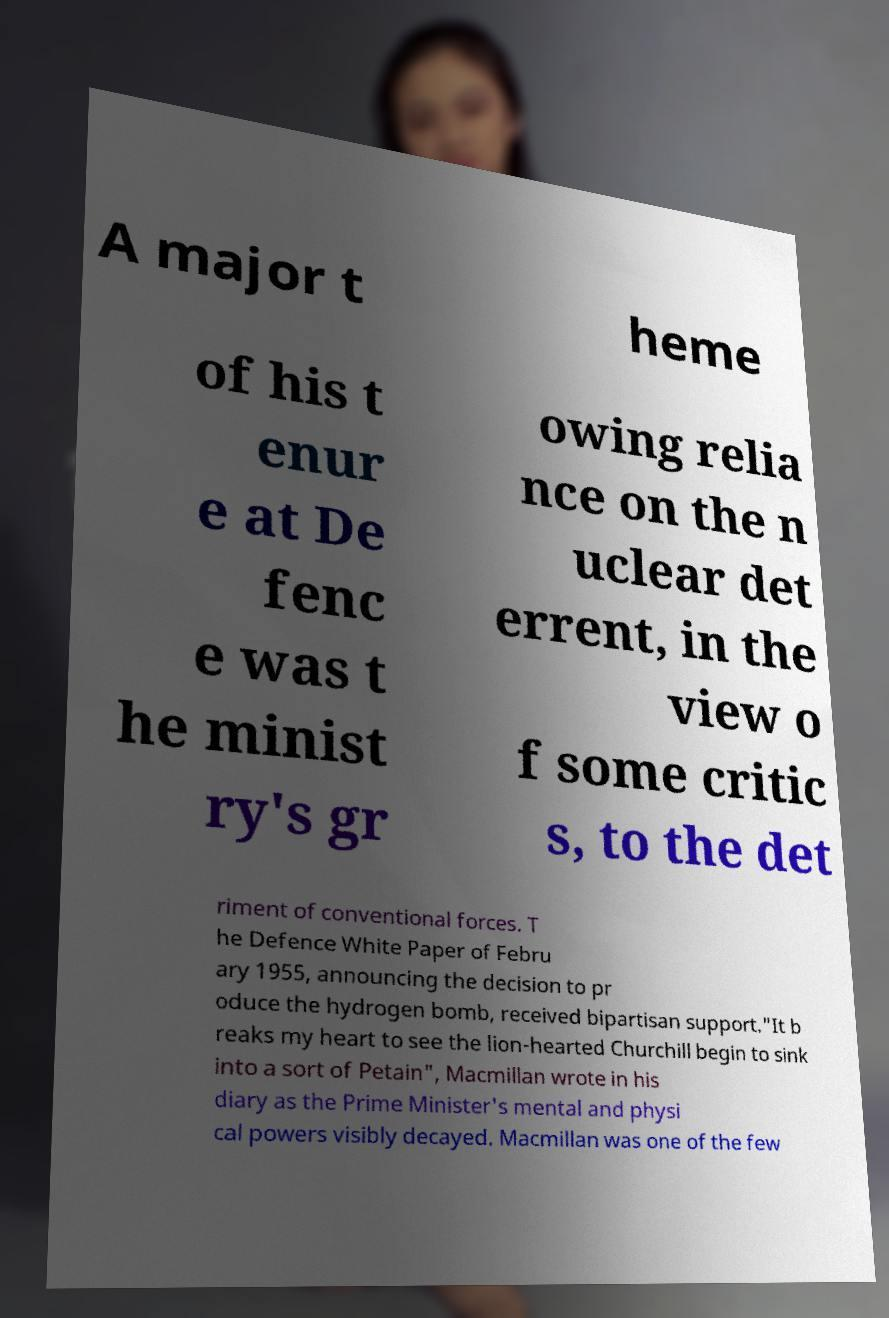What messages or text are displayed in this image? I need them in a readable, typed format. A major t heme of his t enur e at De fenc e was t he minist ry's gr owing relia nce on the n uclear det errent, in the view o f some critic s, to the det riment of conventional forces. T he Defence White Paper of Febru ary 1955, announcing the decision to pr oduce the hydrogen bomb, received bipartisan support."It b reaks my heart to see the lion-hearted Churchill begin to sink into a sort of Petain", Macmillan wrote in his diary as the Prime Minister's mental and physi cal powers visibly decayed. Macmillan was one of the few 